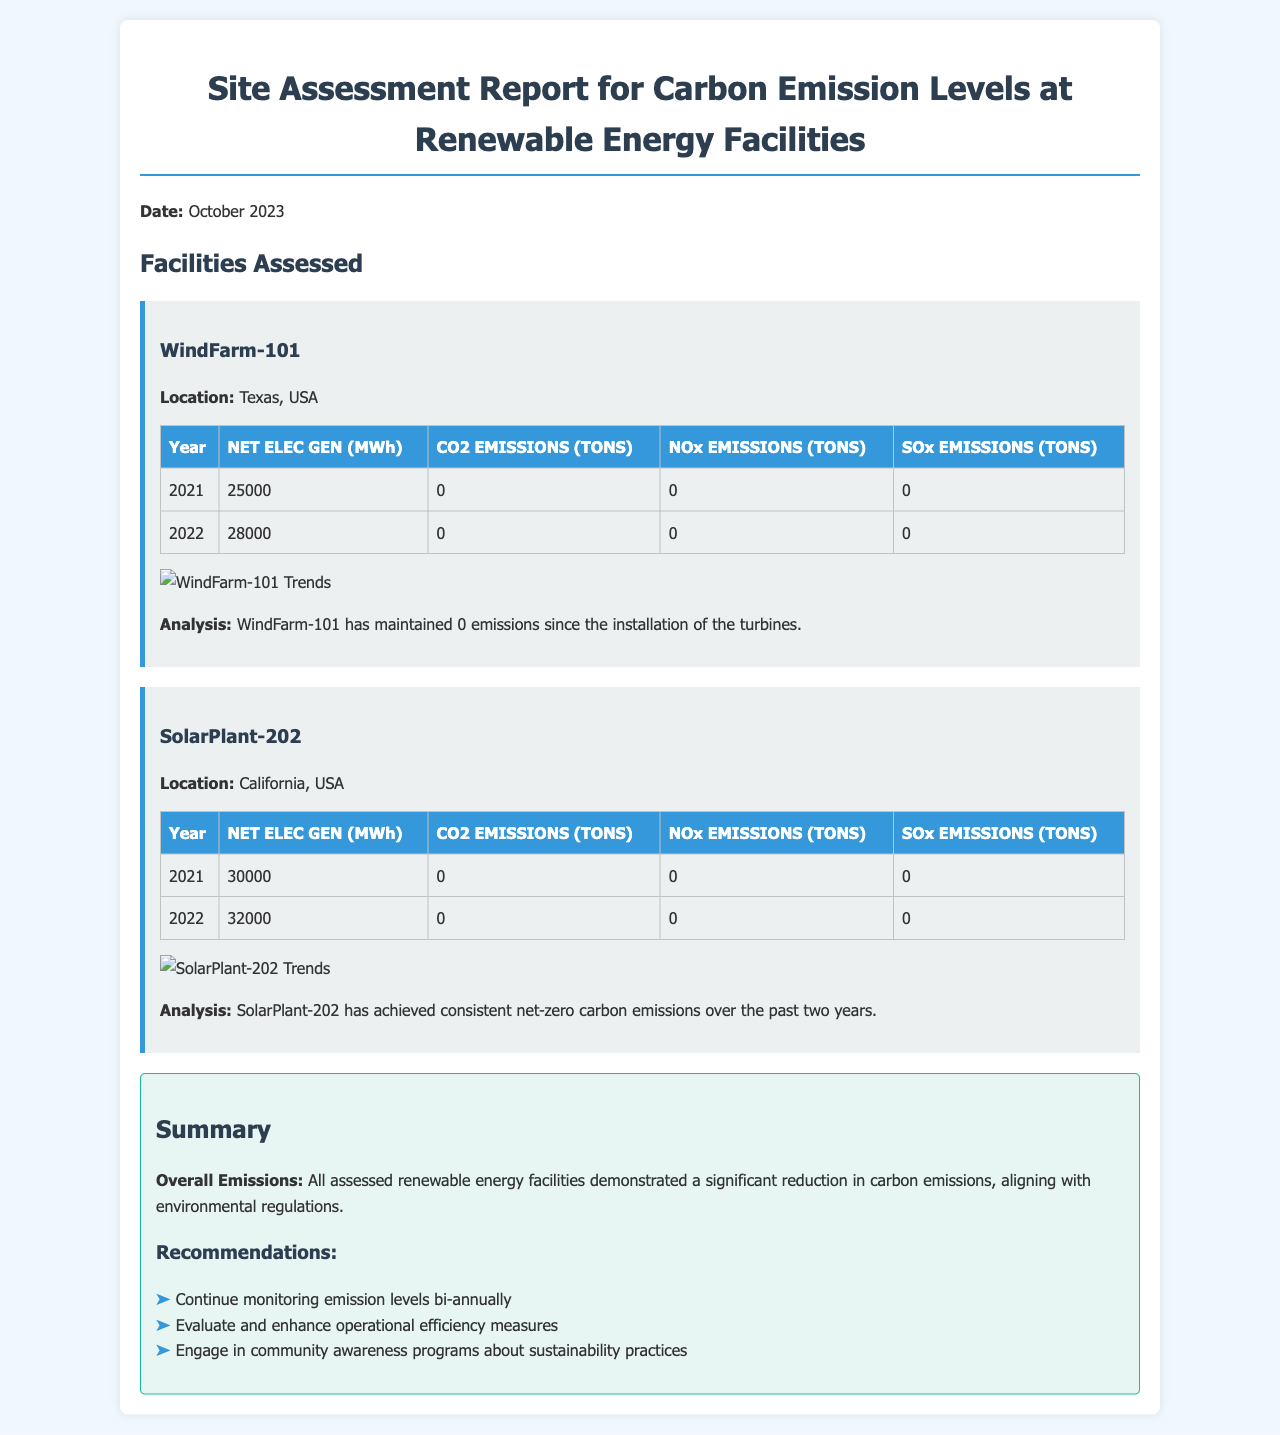What is the location of WindFarm-101? WindFarm-101 is located in Texas, USA.
Answer: Texas, USA What were the CO2 emissions for SolarPlant-202 in 2022? The CO2 emissions for SolarPlant-202 in 2022 are stated as 0 tons.
Answer: 0 tons What year had the highest NET Electricity Generation for WindFarm-101? Comparing the years 2021 and 2022, 2022 had the highest NET Electricity Generation of 28000 MWh.
Answer: 2022 How many tons of NOx emissions were recorded for WindFarm-101? The document indicates that NOx emissions for WindFarm-101 are 0 tons for both years assessed.
Answer: 0 tons What is the overall conclusion regarding emissions for the facilities? The conclusion states that all assessed renewable energy facilities demonstrated a significant reduction in carbon emissions.
Answer: Significant reduction What are the recommendations for monitoring emission levels? The recommendation is to continue monitoring emission levels bi-annually.
Answer: Bi-annually What was the NET Electricity Generation for SolarPlant-202 in 2021? The NET Electricity Generation for SolarPlant-202 in 2021 is given as 30000 MWh.
Answer: 30000 MWh What is the title of the report? The title of the report is "Site Assessment Report for Carbon Emission Levels at Renewable Energy Facilities."
Answer: Site Assessment Report for Carbon Emission Levels at Renewable Energy Facilities What type of facilities were assessed in this report? The facilities assessed in this report are renewable energy facilities.
Answer: Renewable energy facilities 